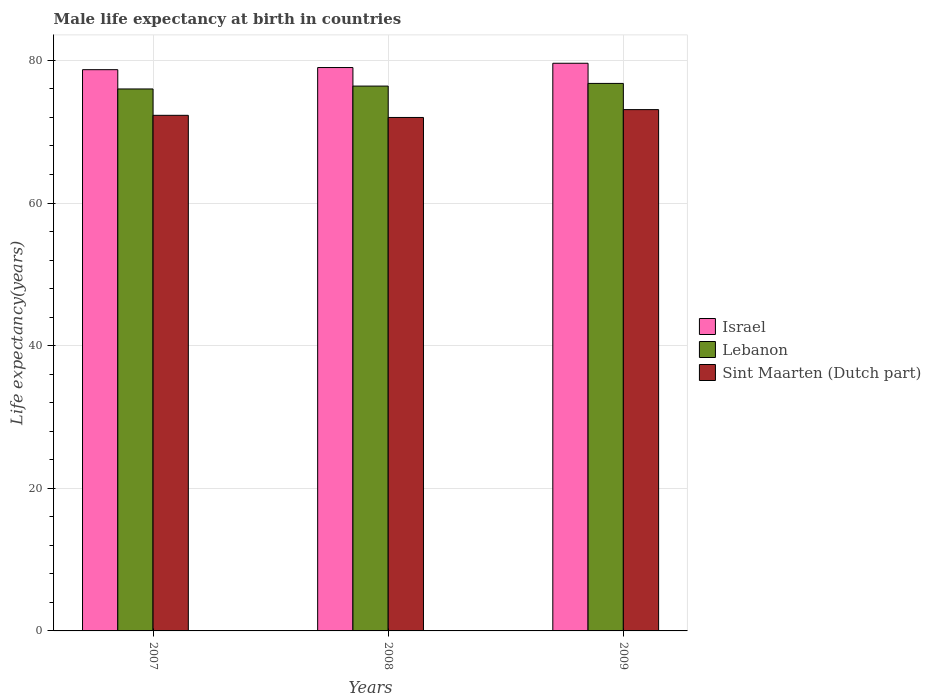Are the number of bars per tick equal to the number of legend labels?
Make the answer very short. Yes. Are the number of bars on each tick of the X-axis equal?
Make the answer very short. Yes. Across all years, what is the maximum male life expectancy at birth in Lebanon?
Your answer should be compact. 76.77. Across all years, what is the minimum male life expectancy at birth in Sint Maarten (Dutch part)?
Offer a very short reply. 72. What is the total male life expectancy at birth in Israel in the graph?
Give a very brief answer. 237.3. What is the difference between the male life expectancy at birth in Lebanon in 2008 and that in 2009?
Offer a very short reply. -0.37. What is the difference between the male life expectancy at birth in Sint Maarten (Dutch part) in 2008 and the male life expectancy at birth in Lebanon in 2007?
Offer a terse response. -4. What is the average male life expectancy at birth in Israel per year?
Offer a very short reply. 79.1. In the year 2009, what is the difference between the male life expectancy at birth in Lebanon and male life expectancy at birth in Israel?
Your answer should be very brief. -2.83. In how many years, is the male life expectancy at birth in Sint Maarten (Dutch part) greater than 8 years?
Your answer should be compact. 3. What is the ratio of the male life expectancy at birth in Israel in 2007 to that in 2008?
Offer a terse response. 1. What is the difference between the highest and the second highest male life expectancy at birth in Lebanon?
Make the answer very short. 0.37. What is the difference between the highest and the lowest male life expectancy at birth in Lebanon?
Make the answer very short. 0.78. In how many years, is the male life expectancy at birth in Israel greater than the average male life expectancy at birth in Israel taken over all years?
Your answer should be very brief. 1. What does the 1st bar from the left in 2008 represents?
Make the answer very short. Israel. What does the 1st bar from the right in 2009 represents?
Offer a terse response. Sint Maarten (Dutch part). How many years are there in the graph?
Keep it short and to the point. 3. What is the difference between two consecutive major ticks on the Y-axis?
Make the answer very short. 20. Does the graph contain any zero values?
Offer a terse response. No. Does the graph contain grids?
Your answer should be compact. Yes. Where does the legend appear in the graph?
Give a very brief answer. Center right. How are the legend labels stacked?
Offer a very short reply. Vertical. What is the title of the graph?
Your answer should be very brief. Male life expectancy at birth in countries. What is the label or title of the Y-axis?
Provide a short and direct response. Life expectancy(years). What is the Life expectancy(years) in Israel in 2007?
Make the answer very short. 78.7. What is the Life expectancy(years) in Lebanon in 2007?
Your response must be concise. 76. What is the Life expectancy(years) of Sint Maarten (Dutch part) in 2007?
Your answer should be compact. 72.3. What is the Life expectancy(years) of Israel in 2008?
Your answer should be very brief. 79. What is the Life expectancy(years) of Lebanon in 2008?
Give a very brief answer. 76.4. What is the Life expectancy(years) of Israel in 2009?
Keep it short and to the point. 79.6. What is the Life expectancy(years) in Lebanon in 2009?
Keep it short and to the point. 76.77. What is the Life expectancy(years) of Sint Maarten (Dutch part) in 2009?
Offer a very short reply. 73.1. Across all years, what is the maximum Life expectancy(years) in Israel?
Provide a succinct answer. 79.6. Across all years, what is the maximum Life expectancy(years) in Lebanon?
Ensure brevity in your answer.  76.77. Across all years, what is the maximum Life expectancy(years) in Sint Maarten (Dutch part)?
Give a very brief answer. 73.1. Across all years, what is the minimum Life expectancy(years) in Israel?
Provide a succinct answer. 78.7. Across all years, what is the minimum Life expectancy(years) in Lebanon?
Provide a succinct answer. 76. Across all years, what is the minimum Life expectancy(years) of Sint Maarten (Dutch part)?
Your answer should be compact. 72. What is the total Life expectancy(years) of Israel in the graph?
Your response must be concise. 237.3. What is the total Life expectancy(years) of Lebanon in the graph?
Make the answer very short. 229.17. What is the total Life expectancy(years) in Sint Maarten (Dutch part) in the graph?
Give a very brief answer. 217.4. What is the difference between the Life expectancy(years) of Lebanon in 2007 and that in 2008?
Offer a very short reply. -0.4. What is the difference between the Life expectancy(years) in Sint Maarten (Dutch part) in 2007 and that in 2008?
Your answer should be compact. 0.3. What is the difference between the Life expectancy(years) in Lebanon in 2007 and that in 2009?
Offer a terse response. -0.78. What is the difference between the Life expectancy(years) of Lebanon in 2008 and that in 2009?
Ensure brevity in your answer.  -0.37. What is the difference between the Life expectancy(years) in Israel in 2007 and the Life expectancy(years) in Lebanon in 2008?
Provide a short and direct response. 2.3. What is the difference between the Life expectancy(years) of Lebanon in 2007 and the Life expectancy(years) of Sint Maarten (Dutch part) in 2008?
Your response must be concise. 4. What is the difference between the Life expectancy(years) of Israel in 2007 and the Life expectancy(years) of Lebanon in 2009?
Offer a very short reply. 1.93. What is the difference between the Life expectancy(years) in Lebanon in 2007 and the Life expectancy(years) in Sint Maarten (Dutch part) in 2009?
Offer a very short reply. 2.9. What is the difference between the Life expectancy(years) in Israel in 2008 and the Life expectancy(years) in Lebanon in 2009?
Your answer should be compact. 2.23. What is the difference between the Life expectancy(years) of Israel in 2008 and the Life expectancy(years) of Sint Maarten (Dutch part) in 2009?
Ensure brevity in your answer.  5.9. What is the difference between the Life expectancy(years) in Lebanon in 2008 and the Life expectancy(years) in Sint Maarten (Dutch part) in 2009?
Offer a terse response. 3.3. What is the average Life expectancy(years) in Israel per year?
Your answer should be very brief. 79.1. What is the average Life expectancy(years) of Lebanon per year?
Your answer should be very brief. 76.39. What is the average Life expectancy(years) of Sint Maarten (Dutch part) per year?
Make the answer very short. 72.47. In the year 2007, what is the difference between the Life expectancy(years) of Israel and Life expectancy(years) of Lebanon?
Offer a very short reply. 2.7. In the year 2007, what is the difference between the Life expectancy(years) of Lebanon and Life expectancy(years) of Sint Maarten (Dutch part)?
Your response must be concise. 3.7. In the year 2008, what is the difference between the Life expectancy(years) in Israel and Life expectancy(years) in Lebanon?
Provide a short and direct response. 2.6. In the year 2008, what is the difference between the Life expectancy(years) in Israel and Life expectancy(years) in Sint Maarten (Dutch part)?
Provide a succinct answer. 7. In the year 2008, what is the difference between the Life expectancy(years) in Lebanon and Life expectancy(years) in Sint Maarten (Dutch part)?
Keep it short and to the point. 4.4. In the year 2009, what is the difference between the Life expectancy(years) in Israel and Life expectancy(years) in Lebanon?
Give a very brief answer. 2.83. In the year 2009, what is the difference between the Life expectancy(years) in Israel and Life expectancy(years) in Sint Maarten (Dutch part)?
Keep it short and to the point. 6.5. In the year 2009, what is the difference between the Life expectancy(years) in Lebanon and Life expectancy(years) in Sint Maarten (Dutch part)?
Offer a very short reply. 3.67. What is the ratio of the Life expectancy(years) in Sint Maarten (Dutch part) in 2007 to that in 2008?
Keep it short and to the point. 1. What is the ratio of the Life expectancy(years) of Israel in 2007 to that in 2009?
Give a very brief answer. 0.99. What is the ratio of the Life expectancy(years) in Lebanon in 2007 to that in 2009?
Provide a succinct answer. 0.99. What is the ratio of the Life expectancy(years) in Sint Maarten (Dutch part) in 2007 to that in 2009?
Make the answer very short. 0.99. What is the ratio of the Life expectancy(years) of Israel in 2008 to that in 2009?
Your response must be concise. 0.99. What is the ratio of the Life expectancy(years) in Lebanon in 2008 to that in 2009?
Your response must be concise. 1. What is the ratio of the Life expectancy(years) of Sint Maarten (Dutch part) in 2008 to that in 2009?
Offer a terse response. 0.98. What is the difference between the highest and the second highest Life expectancy(years) of Lebanon?
Make the answer very short. 0.37. What is the difference between the highest and the lowest Life expectancy(years) in Lebanon?
Offer a very short reply. 0.78. 